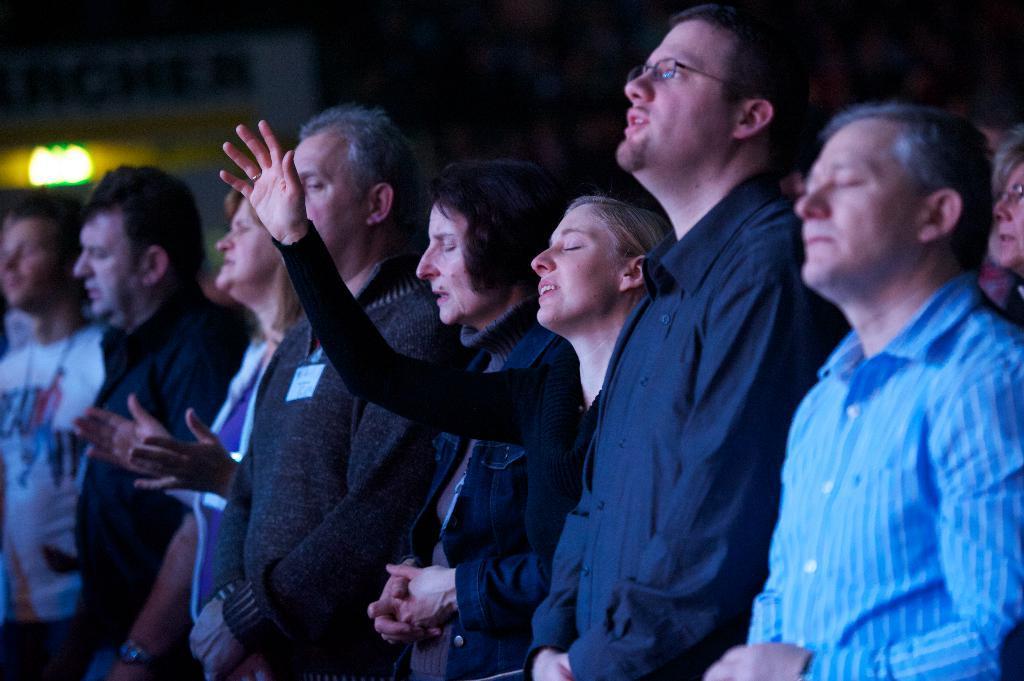Describe this image in one or two sentences. Here we can see group of people. There is a light and we can see dark background. 